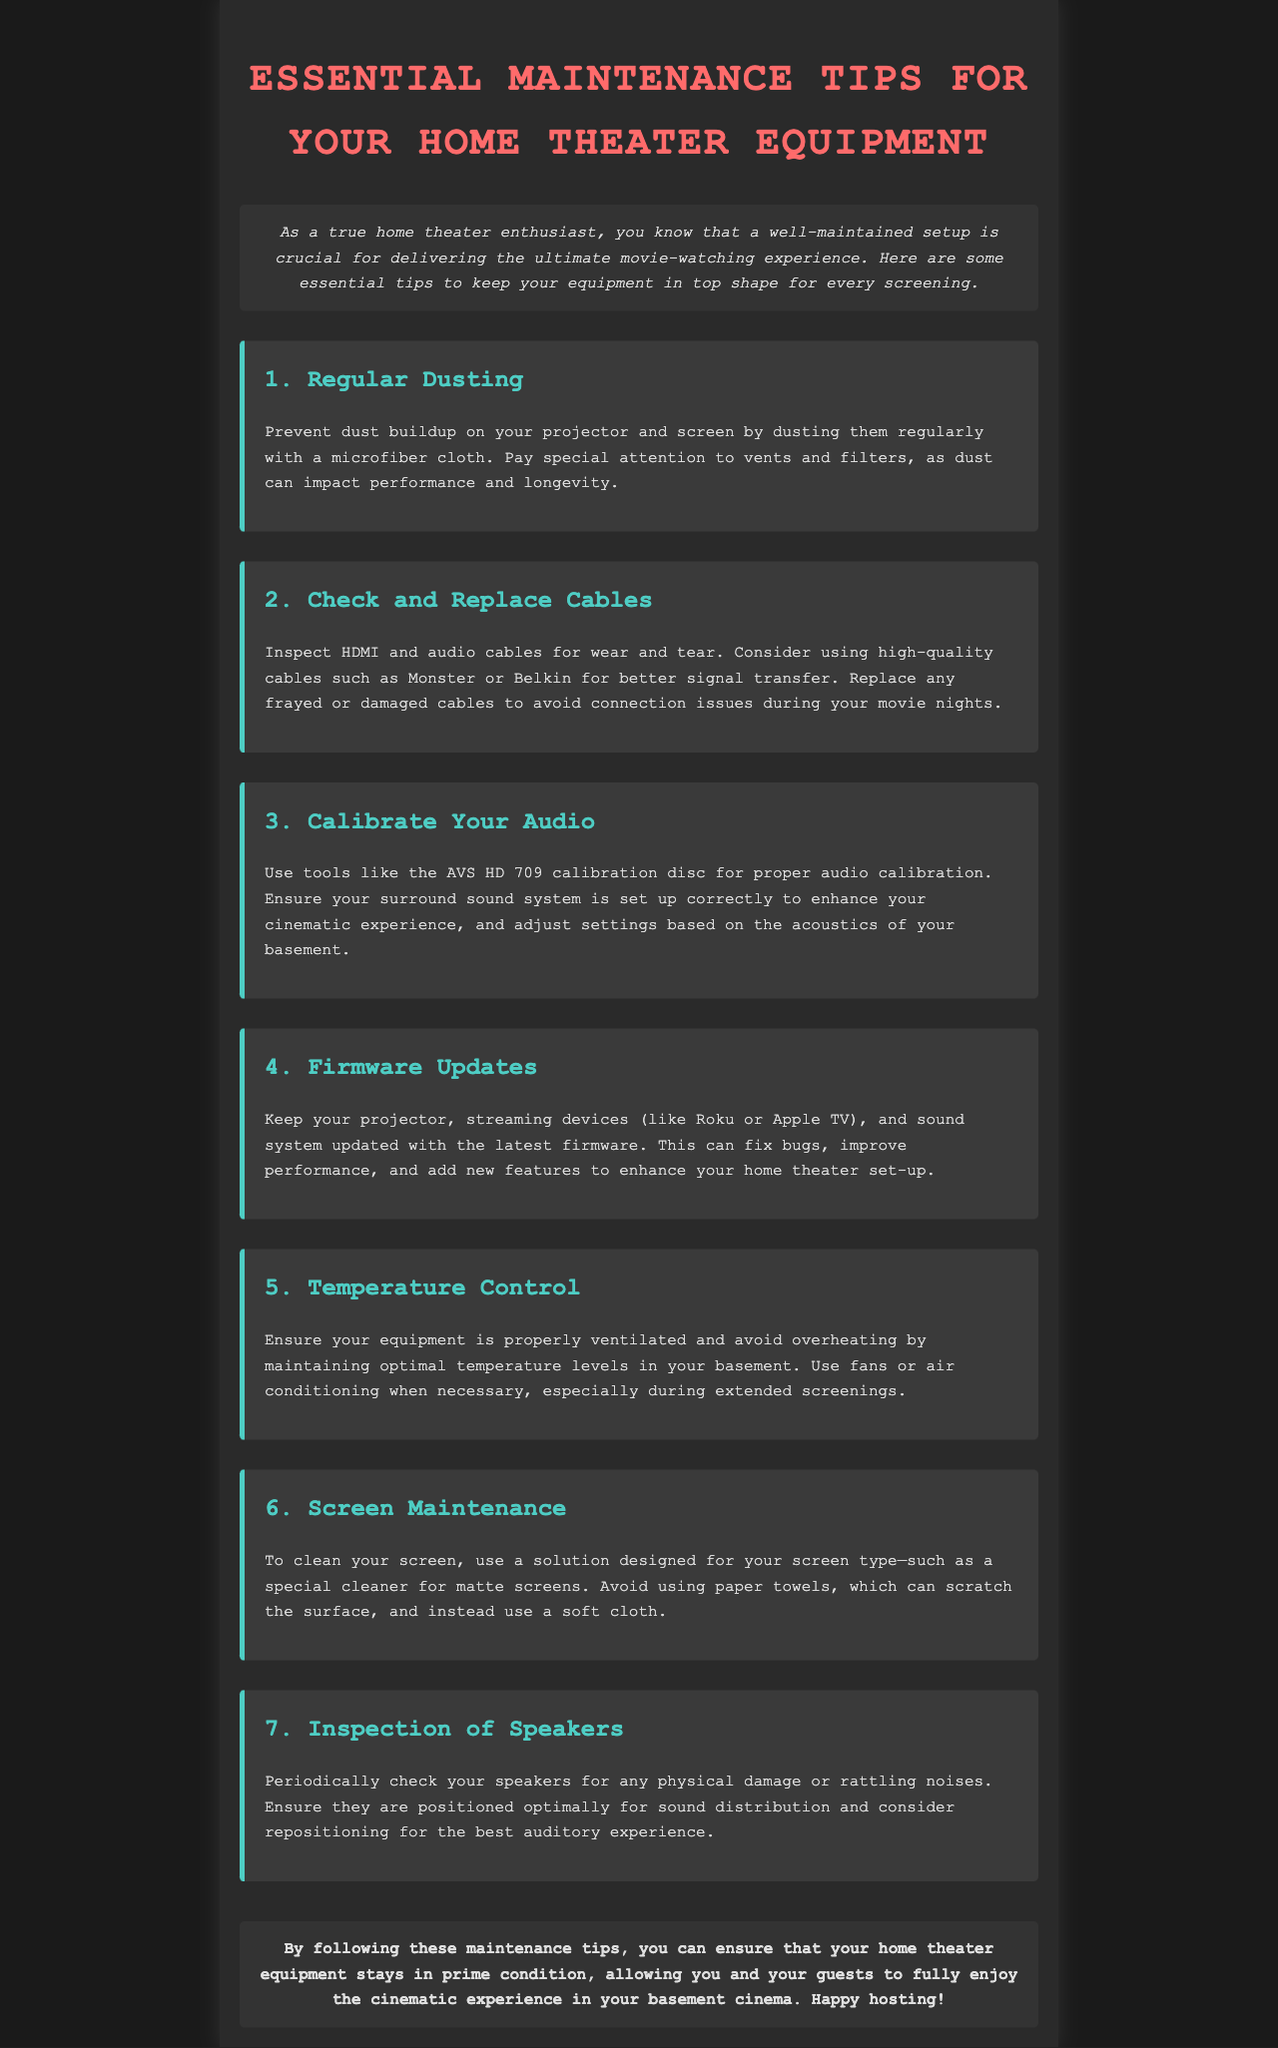What is the title of the newsletter? The title is clearly stated in the heading of the document.
Answer: Essential Maintenance Tips for Your Home Theater Equipment What is the first maintenance tip? The first tip is listed as the first item in the tips section of the document.
Answer: Regular Dusting Which brand of cables is recommended for better signal transfer? The document mentions specific brands in connection with cable recommendations.
Answer: Monster or Belkin How many maintenance tips are provided in total? The total number of tips can be determined by counting the tips listed in the document.
Answer: 7 What should be used to clean a screen? The document specifies what type of solution should be used for screen cleaning in one of the tips.
Answer: A solution designed for your screen type What is emphasized for maintaining temperature? The document discusses an important aspect of temperature control in the equipment maintenance section.
Answer: Proper ventilation Which tool is suggested for audio calibration? The document specifies a tool used during audio calibration as mentioned in one of the tips.
Answer: AVS HD 709 calibration disc 